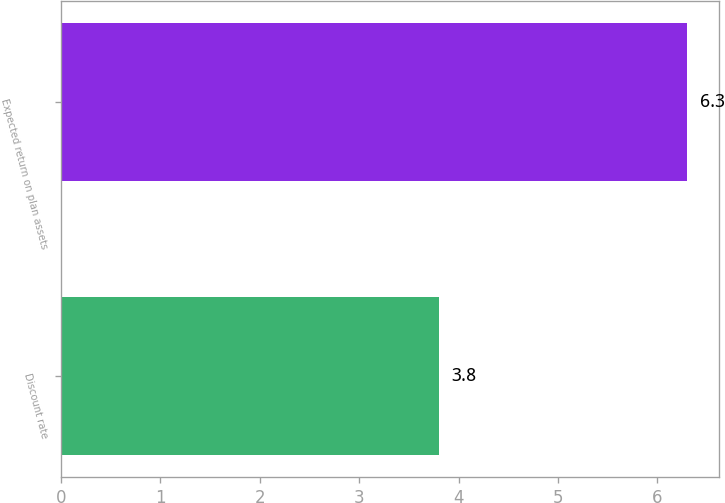Convert chart. <chart><loc_0><loc_0><loc_500><loc_500><bar_chart><fcel>Discount rate<fcel>Expected return on plan assets<nl><fcel>3.8<fcel>6.3<nl></chart> 